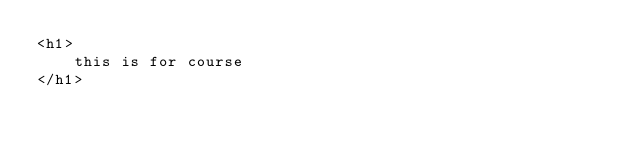<code> <loc_0><loc_0><loc_500><loc_500><_PHP_><h1>
    this is for course
</h1></code> 